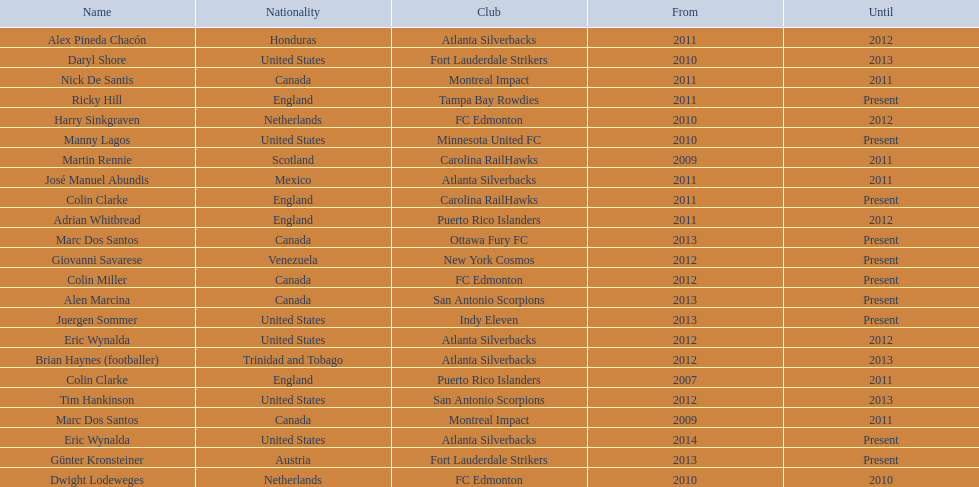What name is listed at the top? José Manuel Abundis. 